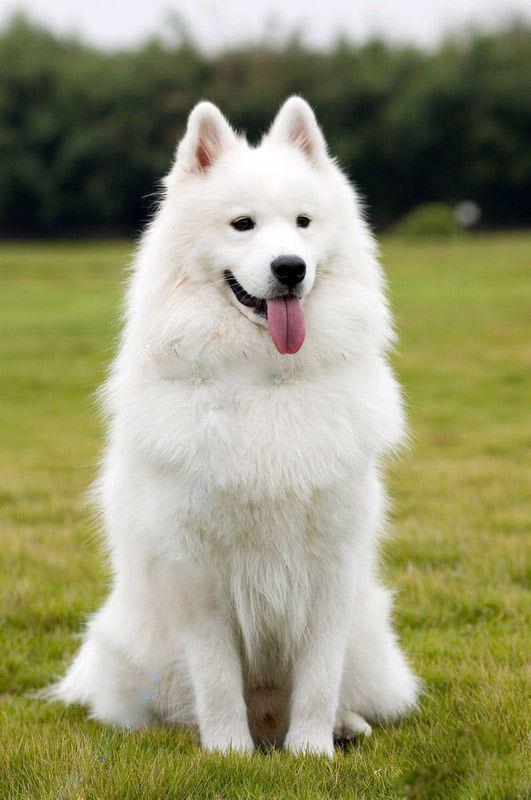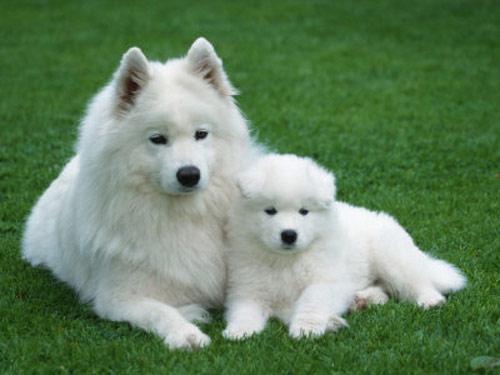The first image is the image on the left, the second image is the image on the right. Given the left and right images, does the statement "All white dogs are sitting in green grass." hold true? Answer yes or no. Yes. The first image is the image on the left, the second image is the image on the right. Examine the images to the left and right. Is the description "At least one of the images shows a dog sitting." accurate? Answer yes or no. Yes. 